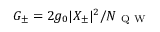Convert formula to latex. <formula><loc_0><loc_0><loc_500><loc_500>G _ { \pm } = 2 g _ { 0 } | X _ { \pm } | ^ { 2 } / N _ { Q W }</formula> 